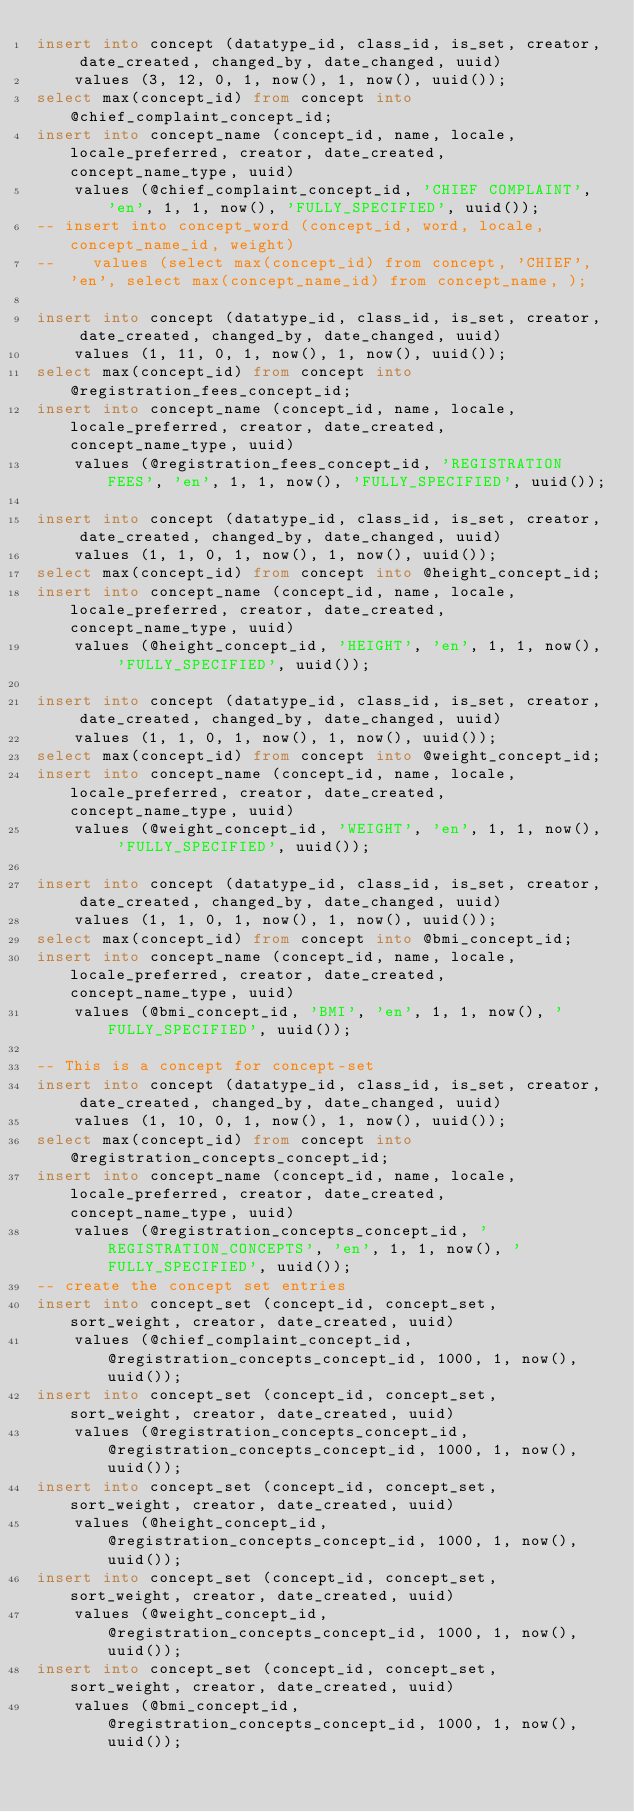Convert code to text. <code><loc_0><loc_0><loc_500><loc_500><_SQL_>insert into concept (datatype_id, class_id, is_set, creator, date_created, changed_by, date_changed, uuid)
    values (3, 12, 0, 1, now(), 1, now(), uuid());
select max(concept_id) from concept into @chief_complaint_concept_id;
insert into concept_name (concept_id, name, locale, locale_preferred, creator, date_created, concept_name_type, uuid)
    values (@chief_complaint_concept_id, 'CHIEF COMPLAINT', 'en', 1, 1, now(), 'FULLY_SPECIFIED', uuid());
-- insert into concept_word (concept_id, word, locale, concept_name_id, weight)
--    values (select max(concept_id) from concept, 'CHIEF', 'en', select max(concept_name_id) from concept_name, );

insert into concept (datatype_id, class_id, is_set, creator, date_created, changed_by, date_changed, uuid)
    values (1, 11, 0, 1, now(), 1, now(), uuid());
select max(concept_id) from concept into @registration_fees_concept_id;
insert into concept_name (concept_id, name, locale, locale_preferred, creator, date_created, concept_name_type, uuid)
    values (@registration_fees_concept_id, 'REGISTRATION FEES', 'en', 1, 1, now(), 'FULLY_SPECIFIED', uuid());

insert into concept (datatype_id, class_id, is_set, creator, date_created, changed_by, date_changed, uuid)
    values (1, 1, 0, 1, now(), 1, now(), uuid());
select max(concept_id) from concept into @height_concept_id;
insert into concept_name (concept_id, name, locale, locale_preferred, creator, date_created, concept_name_type, uuid)
    values (@height_concept_id, 'HEIGHT', 'en', 1, 1, now(), 'FULLY_SPECIFIED', uuid());

insert into concept (datatype_id, class_id, is_set, creator, date_created, changed_by, date_changed, uuid)
    values (1, 1, 0, 1, now(), 1, now(), uuid());
select max(concept_id) from concept into @weight_concept_id;
insert into concept_name (concept_id, name, locale, locale_preferred, creator, date_created, concept_name_type, uuid)
    values (@weight_concept_id, 'WEIGHT', 'en', 1, 1, now(), 'FULLY_SPECIFIED', uuid());

insert into concept (datatype_id, class_id, is_set, creator, date_created, changed_by, date_changed, uuid)
    values (1, 1, 0, 1, now(), 1, now(), uuid());
select max(concept_id) from concept into @bmi_concept_id;
insert into concept_name (concept_id, name, locale, locale_preferred, creator, date_created, concept_name_type, uuid)
    values (@bmi_concept_id, 'BMI', 'en', 1, 1, now(), 'FULLY_SPECIFIED', uuid());

-- This is a concept for concept-set
insert into concept (datatype_id, class_id, is_set, creator, date_created, changed_by, date_changed, uuid)
    values (1, 10, 0, 1, now(), 1, now(), uuid());
select max(concept_id) from concept into @registration_concepts_concept_id;
insert into concept_name (concept_id, name, locale, locale_preferred, creator, date_created, concept_name_type, uuid)
    values (@registration_concepts_concept_id, 'REGISTRATION_CONCEPTS', 'en', 1, 1, now(), 'FULLY_SPECIFIED', uuid());
-- create the concept set entries
insert into concept_set (concept_id, concept_set, sort_weight, creator, date_created, uuid)
    values (@chief_complaint_concept_id, @registration_concepts_concept_id, 1000, 1, now(), uuid());
insert into concept_set (concept_id, concept_set, sort_weight, creator, date_created, uuid)
    values (@registration_concepts_concept_id, @registration_concepts_concept_id, 1000, 1, now(), uuid());
insert into concept_set (concept_id, concept_set, sort_weight, creator, date_created, uuid)
    values (@height_concept_id, @registration_concepts_concept_id, 1000, 1, now(), uuid());
insert into concept_set (concept_id, concept_set, sort_weight, creator, date_created, uuid)
    values (@weight_concept_id, @registration_concepts_concept_id, 1000, 1, now(), uuid());
insert into concept_set (concept_id, concept_set, sort_weight, creator, date_created, uuid)
    values (@bmi_concept_id, @registration_concepts_concept_id, 1000, 1, now(), uuid());</code> 